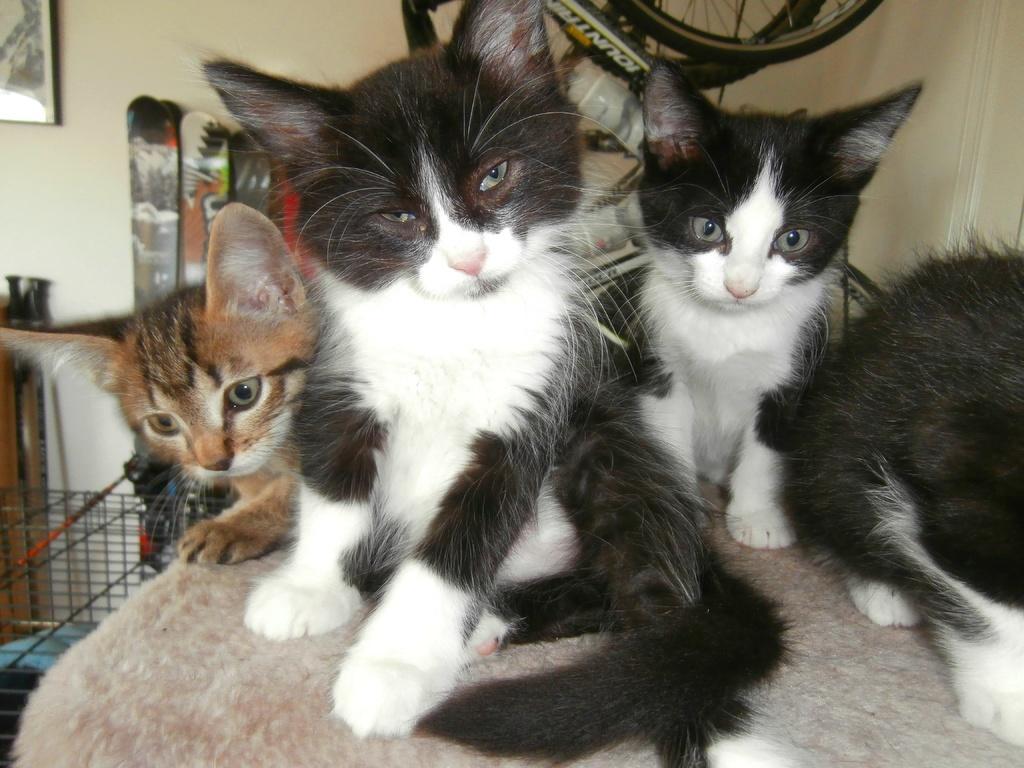Describe this image in one or two sentences. In the foreground of the picture I can see four cats. It is looking like a metal grill cage on the left side. It is looking like a photo frame on the wall on the top left side of the picture. I can see the skateboards on the left side. I can see the bicycle in the background. 